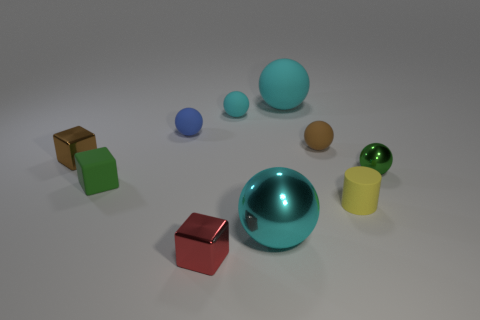Is there any other thing that is made of the same material as the small yellow thing?
Provide a short and direct response. Yes. Are there any other rubber objects that have the same color as the large matte thing?
Your answer should be compact. Yes. How many cyan balls have the same size as the brown rubber ball?
Keep it short and to the point. 1. There is a big object that is in front of the cyan matte object that is behind the small cyan ball; what color is it?
Your response must be concise. Cyan. Are there any red blocks?
Make the answer very short. Yes. Is the shape of the tiny blue rubber thing the same as the green metallic object?
Provide a succinct answer. Yes. What size is the shiny ball that is the same color as the large matte thing?
Provide a short and direct response. Large. There is a small green thing right of the large matte object; how many tiny red shiny cubes are on the right side of it?
Offer a very short reply. 0. What number of small objects are behind the yellow matte cylinder and to the right of the tiny brown rubber thing?
Offer a very short reply. 1. How many objects are large things or rubber blocks on the left side of the small cyan rubber object?
Give a very brief answer. 3. 